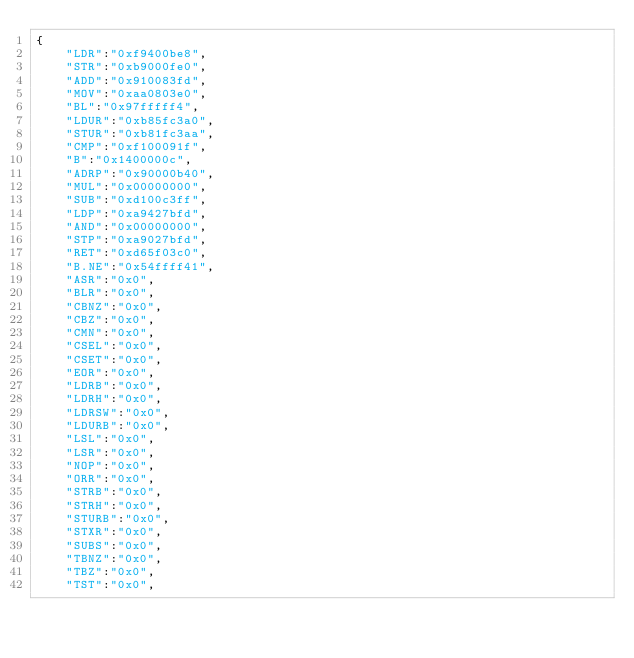Convert code to text. <code><loc_0><loc_0><loc_500><loc_500><_JavaScript_>{
    "LDR":"0xf9400be8",
    "STR":"0xb9000fe0",
    "ADD":"0x910083fd",
    "MOV":"0xaa0803e0",
    "BL":"0x97fffff4",
    "LDUR":"0xb85fc3a0",
    "STUR":"0xb81fc3aa",
    "CMP":"0xf100091f",
    "B":"0x1400000c",
    "ADRP":"0x90000b40",
    "MUL":"0x00000000",
    "SUB":"0xd100c3ff",
    "LDP":"0xa9427bfd",
    "AND":"0x00000000",
    "STP":"0xa9027bfd",
    "RET":"0xd65f03c0",
    "B.NE":"0x54ffff41",
    "ASR":"0x0",
    "BLR":"0x0",
    "CBNZ":"0x0",
    "CBZ":"0x0",
    "CMN":"0x0",
    "CSEL":"0x0",
    "CSET":"0x0",
    "EOR":"0x0",
    "LDRB":"0x0",
    "LDRH":"0x0",
    "LDRSW":"0x0",
    "LDURB":"0x0",
    "LSL":"0x0",
    "LSR":"0x0",
    "NOP":"0x0",
    "ORR":"0x0",
    "STRB":"0x0",
    "STRH":"0x0",
    "STURB":"0x0",
    "STXR":"0x0",
    "SUBS":"0x0",
    "TBNZ":"0x0",
    "TBZ":"0x0",
    "TST":"0x0",</code> 